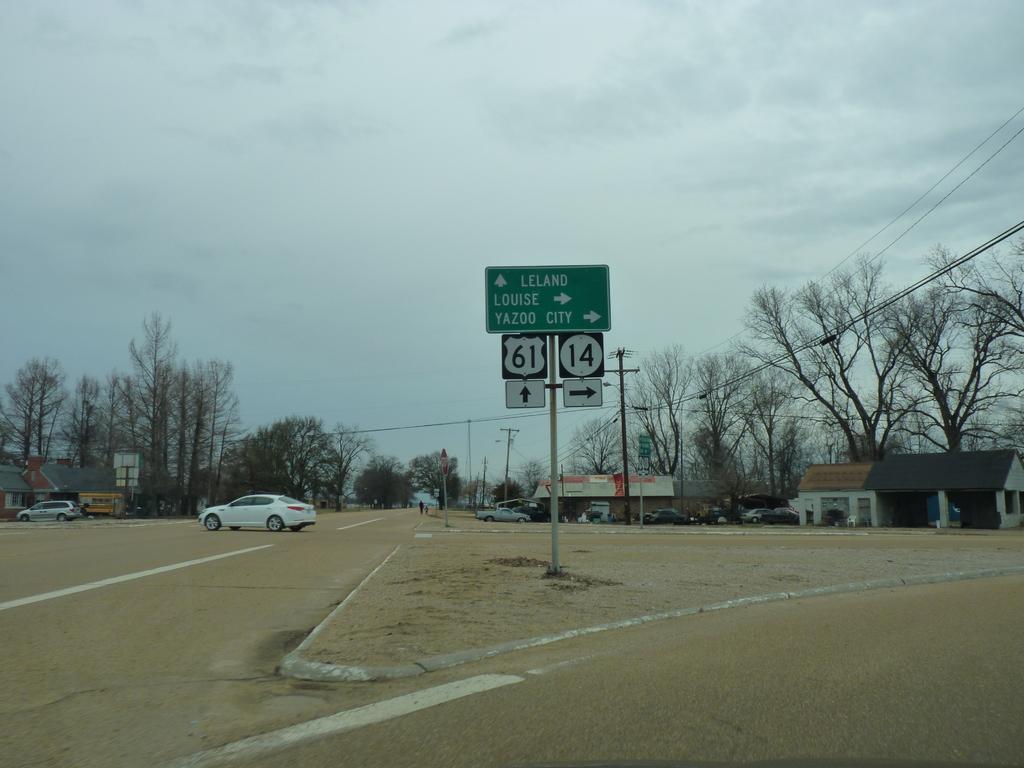What is the route number is you go right?
Provide a succinct answer. 14. 